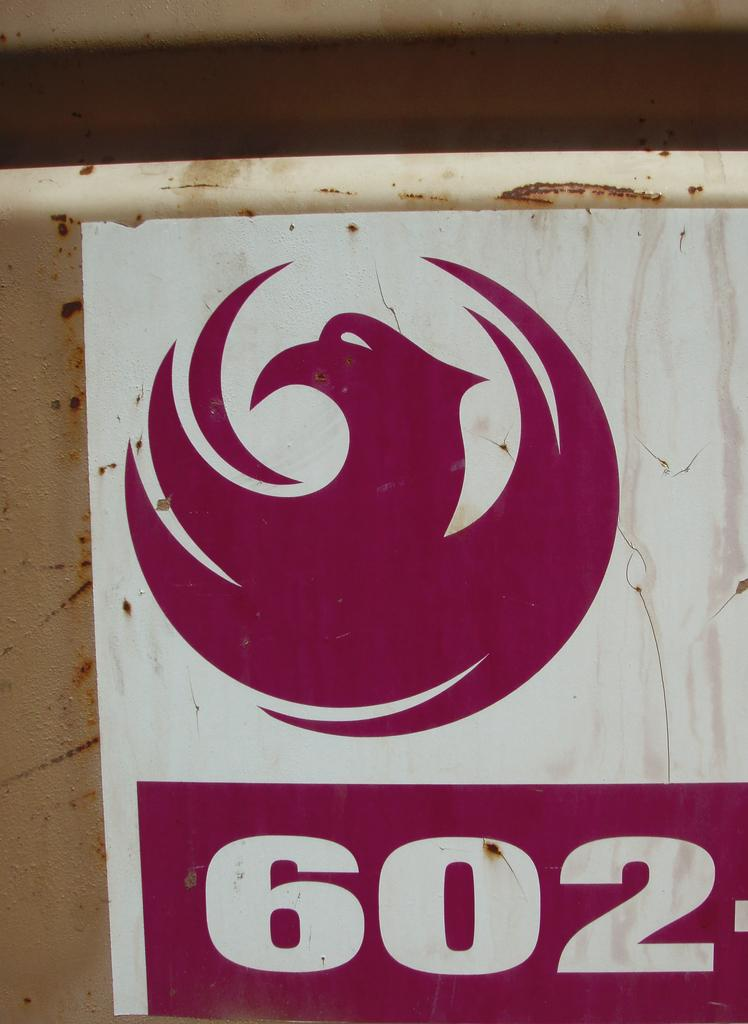<image>
Offer a succinct explanation of the picture presented. A marroon and white sign with a bird like logo and 602 on it. 